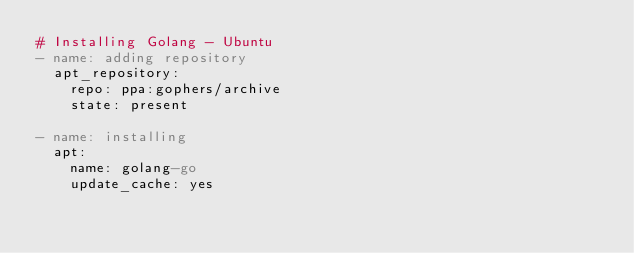<code> <loc_0><loc_0><loc_500><loc_500><_YAML_># Installing Golang - Ubuntu
- name: adding repository
  apt_repository:
    repo: ppa:gophers/archive
    state: present

- name: installing
  apt:
    name: golang-go
    update_cache: yes
</code> 